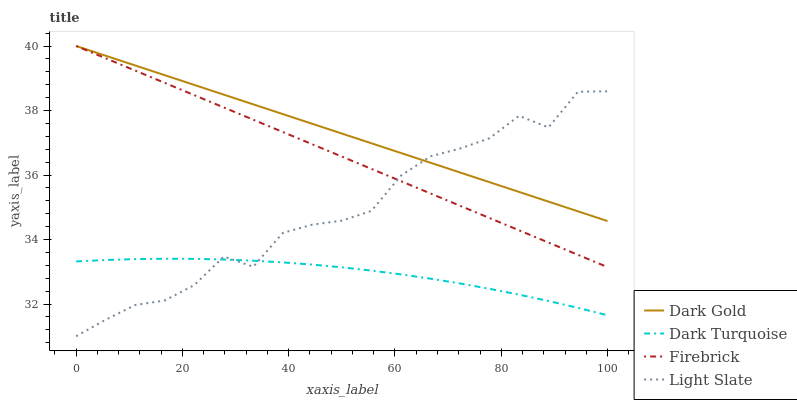Does Dark Turquoise have the minimum area under the curve?
Answer yes or no. Yes. Does Dark Gold have the maximum area under the curve?
Answer yes or no. Yes. Does Firebrick have the minimum area under the curve?
Answer yes or no. No. Does Firebrick have the maximum area under the curve?
Answer yes or no. No. Is Dark Gold the smoothest?
Answer yes or no. Yes. Is Light Slate the roughest?
Answer yes or no. Yes. Is Dark Turquoise the smoothest?
Answer yes or no. No. Is Dark Turquoise the roughest?
Answer yes or no. No. Does Light Slate have the lowest value?
Answer yes or no. Yes. Does Dark Turquoise have the lowest value?
Answer yes or no. No. Does Dark Gold have the highest value?
Answer yes or no. Yes. Does Dark Turquoise have the highest value?
Answer yes or no. No. Is Dark Turquoise less than Firebrick?
Answer yes or no. Yes. Is Firebrick greater than Dark Turquoise?
Answer yes or no. Yes. Does Dark Gold intersect Light Slate?
Answer yes or no. Yes. Is Dark Gold less than Light Slate?
Answer yes or no. No. Is Dark Gold greater than Light Slate?
Answer yes or no. No. Does Dark Turquoise intersect Firebrick?
Answer yes or no. No. 